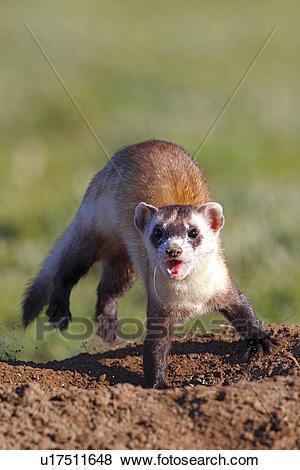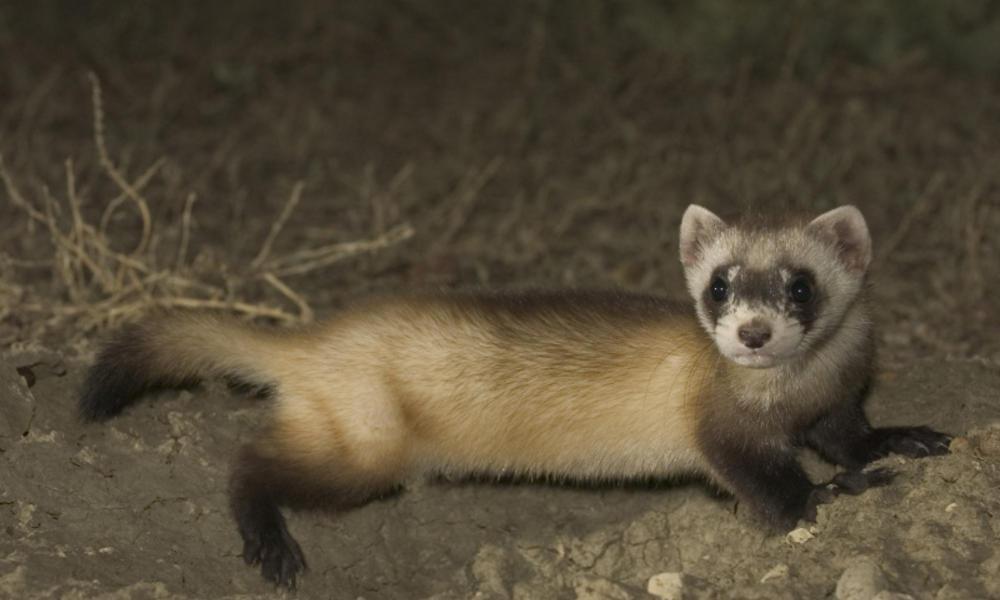The first image is the image on the left, the second image is the image on the right. Considering the images on both sides, is "At least one ferret is emerging from a hole and looking in the distance." valid? Answer yes or no. No. The first image is the image on the left, the second image is the image on the right. For the images shown, is this caption "In the image on the right, a small portion of the ferret's body is occluded by some of the grass." true? Answer yes or no. No. 